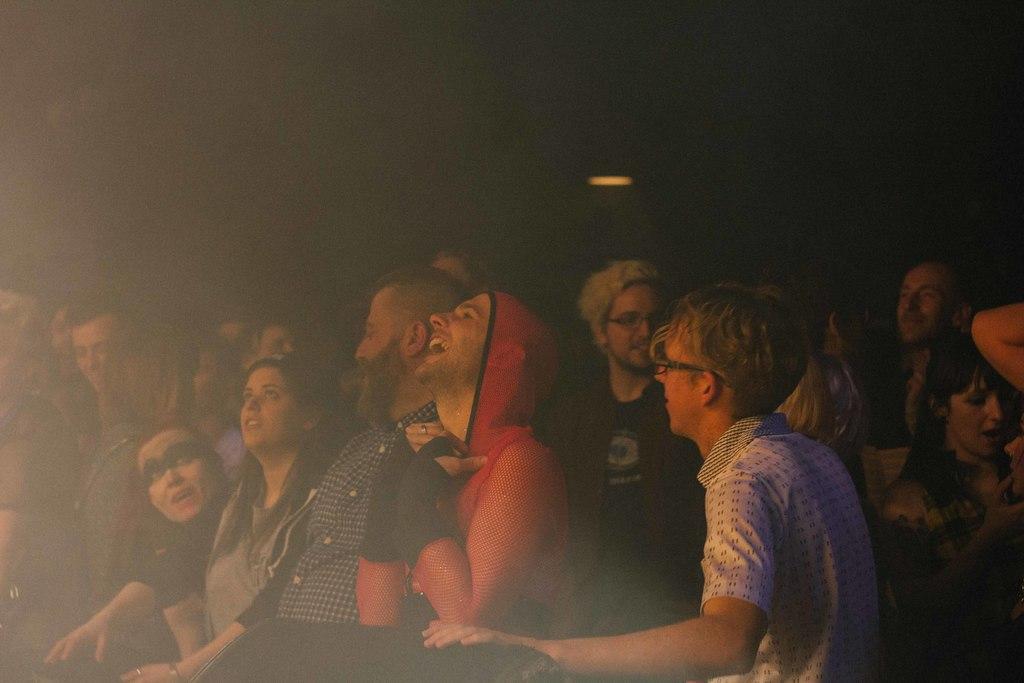Could you give a brief overview of what you see in this image? In this picture I can see group of people, and there is dark background. 